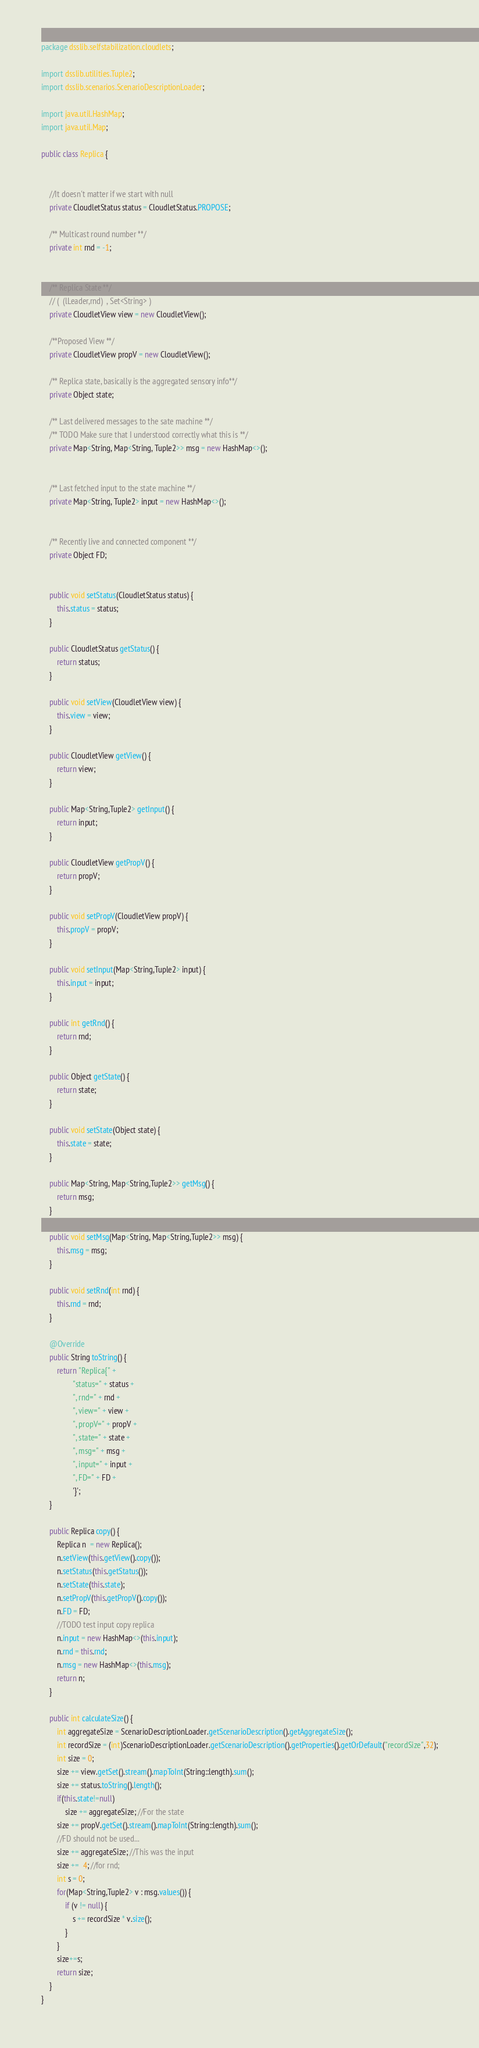<code> <loc_0><loc_0><loc_500><loc_500><_Java_>package dsslib.selfstabilization.cloudlets;

import dsslib.utilities.Tuple2;
import dsslib.scenarios.ScenarioDescriptionLoader;

import java.util.HashMap;
import java.util.Map;

public class Replica {


    //It doesn't matter if we start with null
    private CloudletStatus status = CloudletStatus.PROPOSE;

    /** Multicast round number **/
    private int rnd = -1;


    /** Replica State **/
    // (  (lLeader,rnd)  , Set<String> )
    private CloudletView view = new CloudletView();

    /**Proposed View **/
    private CloudletView propV = new CloudletView();

    /** Replica state, basically is the aggregated sensory info**/
    private Object state;

    /** Last delivered messages to the sate machine **/
    /** TODO Make sure that I understood correctly what this is **/
    private Map<String, Map<String, Tuple2>> msg = new HashMap<>();


    /** Last fetched input to the state machine **/
    private Map<String, Tuple2> input = new HashMap<>();


    /** Recently live and connected component **/
    private Object FD;


    public void setStatus(CloudletStatus status) {
        this.status = status;
    }

    public CloudletStatus getStatus() {
        return status;
    }

    public void setView(CloudletView view) {
        this.view = view;
    }

    public CloudletView getView() {
        return view;
    }

    public Map<String,Tuple2> getInput() {
        return input;
    }

    public CloudletView getPropV() {
        return propV;
    }

    public void setPropV(CloudletView propV) {
        this.propV = propV;
    }

    public void setInput(Map<String,Tuple2> input) {
        this.input = input;
    }

    public int getRnd() {
        return rnd;
    }

    public Object getState() {
        return state;
    }

    public void setState(Object state) {
        this.state = state;
    }

    public Map<String, Map<String,Tuple2>> getMsg() {
        return msg;
    }

    public void setMsg(Map<String, Map<String,Tuple2>> msg) {
        this.msg = msg;
    }

    public void setRnd(int rnd) {
        this.rnd = rnd;
    }

    @Override
    public String toString() {
        return "Replica{" +
                "status=" + status +
                ", rnd=" + rnd +
                ", view=" + view +
                ", propV=" + propV +
                ", state=" + state +
                ", msg=" + msg +
                ", input=" + input +
                ", FD=" + FD +
                '}';
    }

    public Replica copy() {
        Replica n  = new Replica();
        n.setView(this.getView().copy());
        n.setStatus(this.getStatus());
        n.setState(this.state);
        n.setPropV(this.getPropV().copy());
        n.FD = FD;
        //TODO test input copy replica
        n.input = new HashMap<>(this.input);
        n.rnd = this.rnd;
        n.msg = new HashMap<>(this.msg);
        return n;
    }

    public int calculateSize() {
        int aggregateSize = ScenarioDescriptionLoader.getScenarioDescription().getAggregateSize();
        int recordSize = (int)ScenarioDescriptionLoader.getScenarioDescription().getProperties().getOrDefault("recordSize",32);
        int size = 0;
        size += view.getSet().stream().mapToInt(String::length).sum();
        size += status.toString().length();
        if(this.state!=null)
            size += aggregateSize; //For the state
        size += propV.getSet().stream().mapToInt(String::length).sum();
        //FD should not be used...
        size += aggregateSize; //This was the input
        size +=  4; //for rnd;
        int s = 0;
        for(Map<String,Tuple2> v : msg.values()) {
            if (v != null) {
                s += recordSize * v.size();
            }
        }
        size+=s;
        return size;
    }
}
</code> 